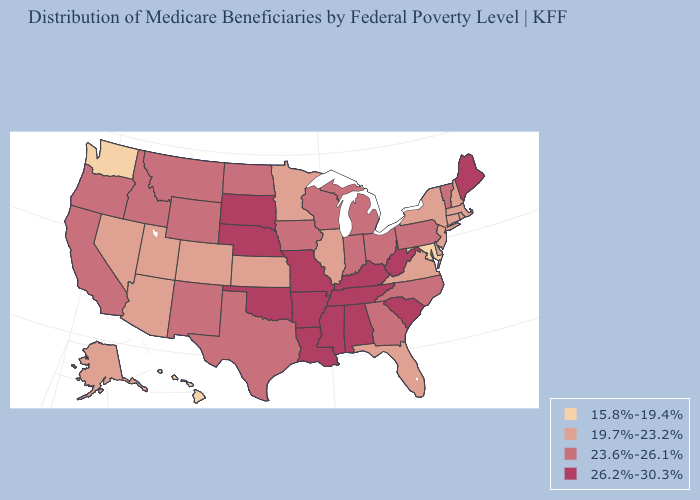Is the legend a continuous bar?
Short answer required. No. Name the states that have a value in the range 26.2%-30.3%?
Quick response, please. Alabama, Arkansas, Kentucky, Louisiana, Maine, Mississippi, Missouri, Nebraska, Oklahoma, South Carolina, South Dakota, Tennessee, West Virginia. What is the value of Michigan?
Write a very short answer. 23.6%-26.1%. Does Mississippi have a higher value than New Hampshire?
Keep it brief. Yes. Does Maine have the same value as Tennessee?
Keep it brief. Yes. Name the states that have a value in the range 19.7%-23.2%?
Quick response, please. Alaska, Arizona, Colorado, Connecticut, Delaware, Florida, Illinois, Kansas, Massachusetts, Minnesota, Nevada, New Hampshire, New Jersey, New York, Rhode Island, Utah, Virginia. Does the first symbol in the legend represent the smallest category?
Be succinct. Yes. What is the value of Maryland?
Quick response, please. 15.8%-19.4%. Name the states that have a value in the range 15.8%-19.4%?
Answer briefly. Hawaii, Maryland, Washington. Does Idaho have a lower value than California?
Be succinct. No. Among the states that border Arkansas , which have the lowest value?
Write a very short answer. Texas. Is the legend a continuous bar?
Be succinct. No. Name the states that have a value in the range 26.2%-30.3%?
Keep it brief. Alabama, Arkansas, Kentucky, Louisiana, Maine, Mississippi, Missouri, Nebraska, Oklahoma, South Carolina, South Dakota, Tennessee, West Virginia. What is the value of Nevada?
Concise answer only. 19.7%-23.2%. 